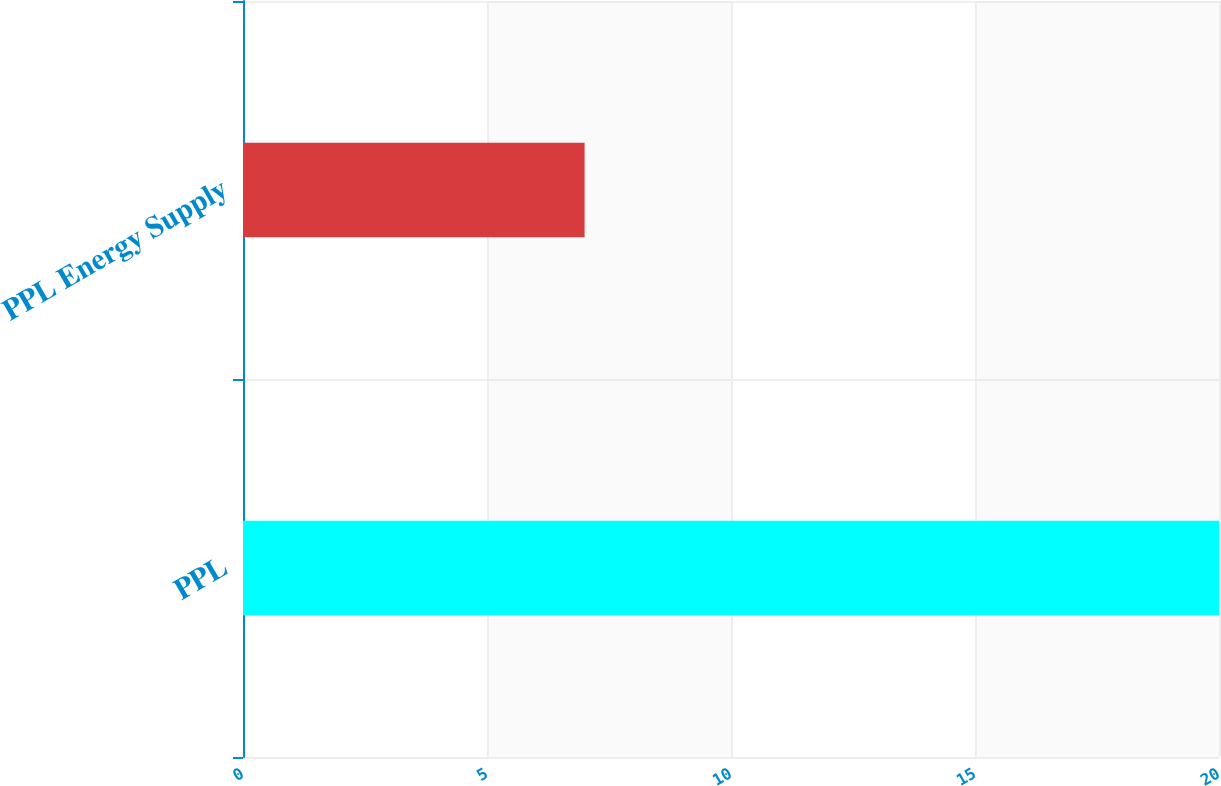Convert chart. <chart><loc_0><loc_0><loc_500><loc_500><bar_chart><fcel>PPL<fcel>PPL Energy Supply<nl><fcel>20<fcel>7<nl></chart> 